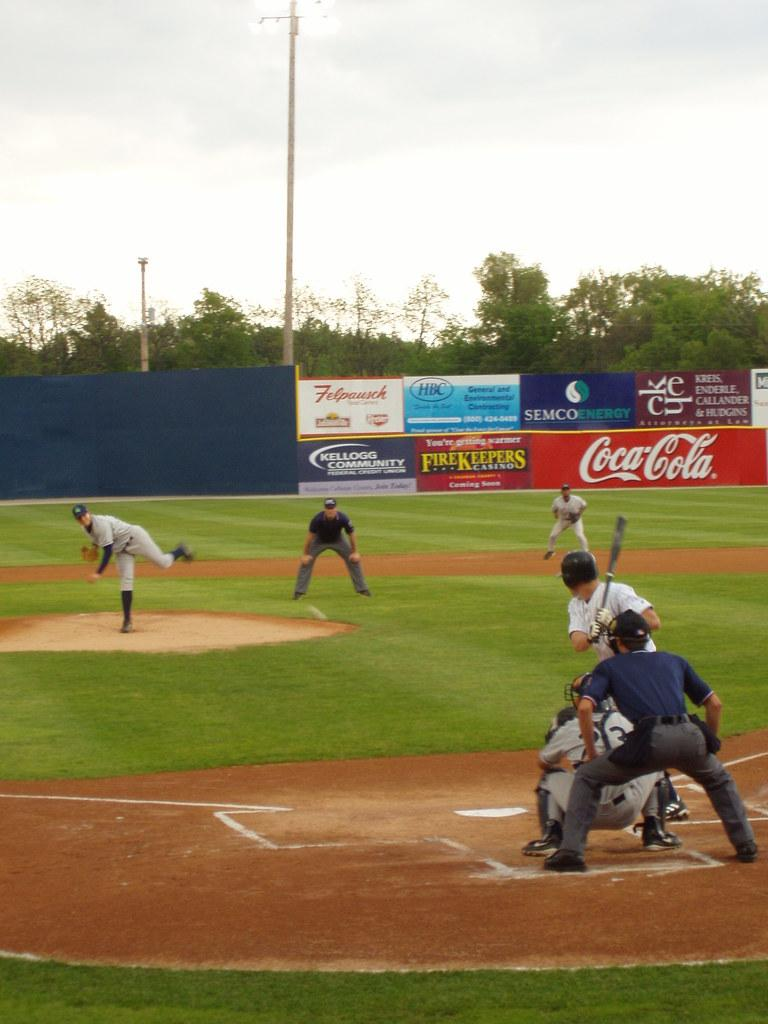<image>
Summarize the visual content of the image. People playing baseball in a park with Coca Cola ads. 